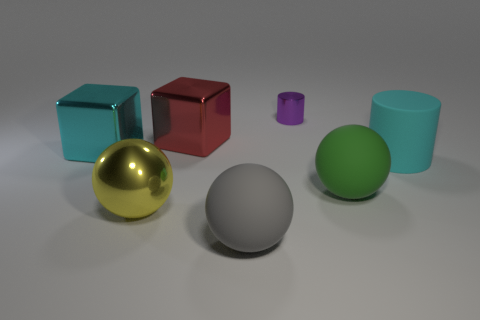Subtract all yellow metallic spheres. How many spheres are left? 2 Add 2 cyan rubber objects. How many objects exist? 9 Subtract all large cyan cylinders. Subtract all big cyan metallic blocks. How many objects are left? 5 Add 7 small cylinders. How many small cylinders are left? 8 Add 2 large rubber things. How many large rubber things exist? 5 Subtract all red blocks. How many blocks are left? 1 Subtract 1 red cubes. How many objects are left? 6 Subtract all balls. How many objects are left? 4 Subtract 1 spheres. How many spheres are left? 2 Subtract all red cylinders. Subtract all purple spheres. How many cylinders are left? 2 